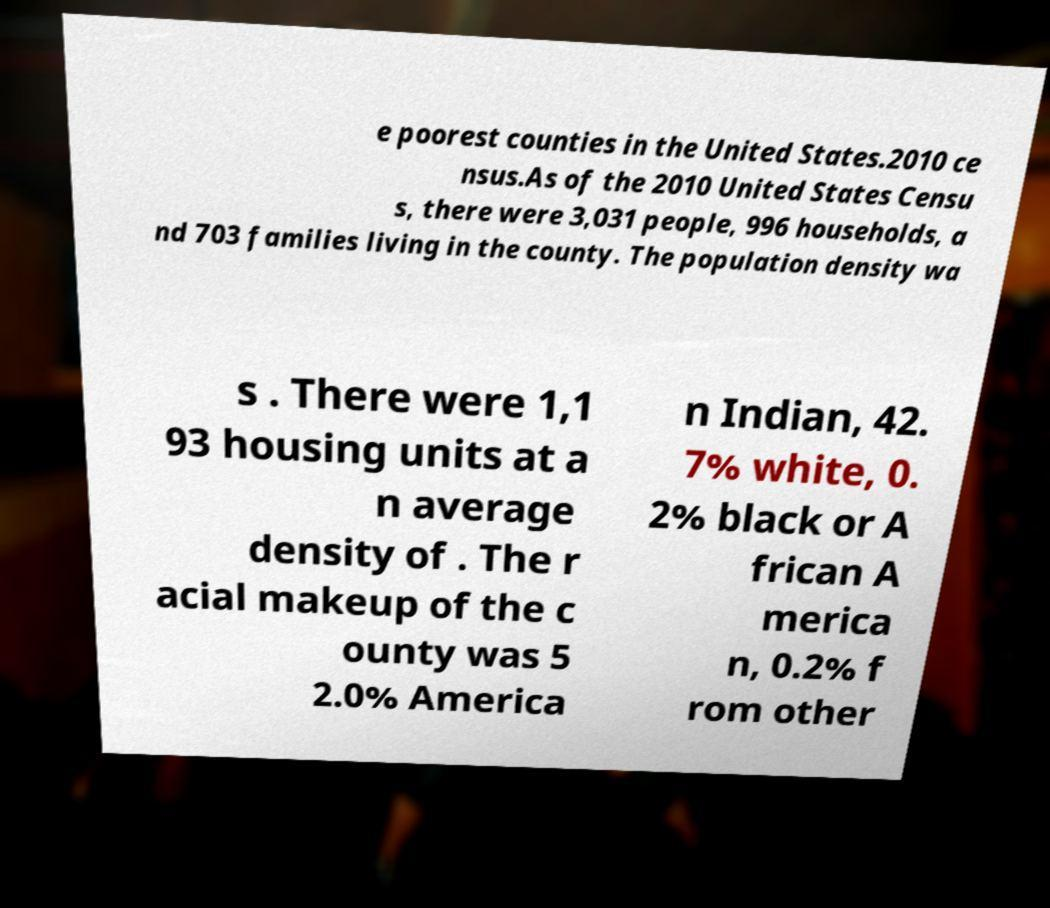What messages or text are displayed in this image? I need them in a readable, typed format. e poorest counties in the United States.2010 ce nsus.As of the 2010 United States Censu s, there were 3,031 people, 996 households, a nd 703 families living in the county. The population density wa s . There were 1,1 93 housing units at a n average density of . The r acial makeup of the c ounty was 5 2.0% America n Indian, 42. 7% white, 0. 2% black or A frican A merica n, 0.2% f rom other 